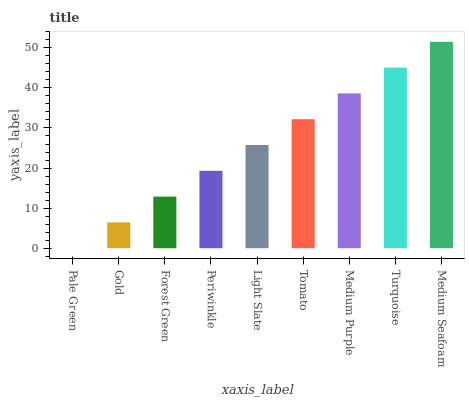Is Gold the minimum?
Answer yes or no. No. Is Gold the maximum?
Answer yes or no. No. Is Gold greater than Pale Green?
Answer yes or no. Yes. Is Pale Green less than Gold?
Answer yes or no. Yes. Is Pale Green greater than Gold?
Answer yes or no. No. Is Gold less than Pale Green?
Answer yes or no. No. Is Light Slate the high median?
Answer yes or no. Yes. Is Light Slate the low median?
Answer yes or no. Yes. Is Medium Purple the high median?
Answer yes or no. No. Is Turquoise the low median?
Answer yes or no. No. 